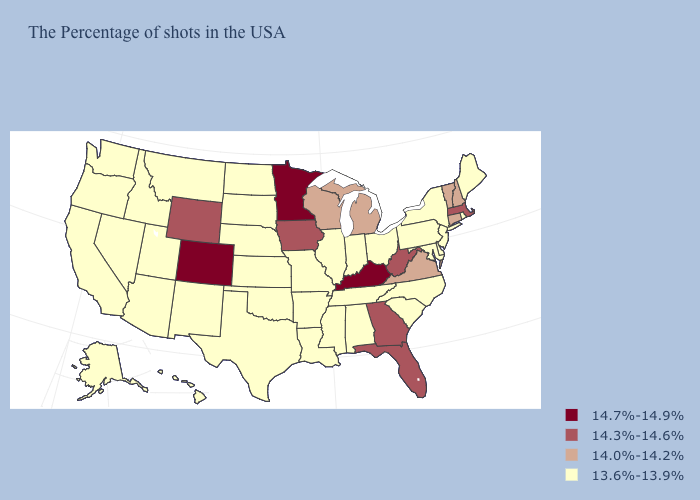How many symbols are there in the legend?
Answer briefly. 4. Name the states that have a value in the range 14.7%-14.9%?
Be succinct. Kentucky, Minnesota, Colorado. Name the states that have a value in the range 13.6%-13.9%?
Be succinct. Maine, Rhode Island, New York, New Jersey, Delaware, Maryland, Pennsylvania, North Carolina, South Carolina, Ohio, Indiana, Alabama, Tennessee, Illinois, Mississippi, Louisiana, Missouri, Arkansas, Kansas, Nebraska, Oklahoma, Texas, South Dakota, North Dakota, New Mexico, Utah, Montana, Arizona, Idaho, Nevada, California, Washington, Oregon, Alaska, Hawaii. Name the states that have a value in the range 13.6%-13.9%?
Concise answer only. Maine, Rhode Island, New York, New Jersey, Delaware, Maryland, Pennsylvania, North Carolina, South Carolina, Ohio, Indiana, Alabama, Tennessee, Illinois, Mississippi, Louisiana, Missouri, Arkansas, Kansas, Nebraska, Oklahoma, Texas, South Dakota, North Dakota, New Mexico, Utah, Montana, Arizona, Idaho, Nevada, California, Washington, Oregon, Alaska, Hawaii. Name the states that have a value in the range 14.3%-14.6%?
Keep it brief. Massachusetts, West Virginia, Florida, Georgia, Iowa, Wyoming. Which states have the lowest value in the MidWest?
Write a very short answer. Ohio, Indiana, Illinois, Missouri, Kansas, Nebraska, South Dakota, North Dakota. Which states have the lowest value in the Northeast?
Give a very brief answer. Maine, Rhode Island, New York, New Jersey, Pennsylvania. Name the states that have a value in the range 13.6%-13.9%?
Be succinct. Maine, Rhode Island, New York, New Jersey, Delaware, Maryland, Pennsylvania, North Carolina, South Carolina, Ohio, Indiana, Alabama, Tennessee, Illinois, Mississippi, Louisiana, Missouri, Arkansas, Kansas, Nebraska, Oklahoma, Texas, South Dakota, North Dakota, New Mexico, Utah, Montana, Arizona, Idaho, Nevada, California, Washington, Oregon, Alaska, Hawaii. Name the states that have a value in the range 13.6%-13.9%?
Be succinct. Maine, Rhode Island, New York, New Jersey, Delaware, Maryland, Pennsylvania, North Carolina, South Carolina, Ohio, Indiana, Alabama, Tennessee, Illinois, Mississippi, Louisiana, Missouri, Arkansas, Kansas, Nebraska, Oklahoma, Texas, South Dakota, North Dakota, New Mexico, Utah, Montana, Arizona, Idaho, Nevada, California, Washington, Oregon, Alaska, Hawaii. Name the states that have a value in the range 14.7%-14.9%?
Give a very brief answer. Kentucky, Minnesota, Colorado. Which states have the lowest value in the South?
Give a very brief answer. Delaware, Maryland, North Carolina, South Carolina, Alabama, Tennessee, Mississippi, Louisiana, Arkansas, Oklahoma, Texas. Among the states that border Arizona , which have the lowest value?
Short answer required. New Mexico, Utah, Nevada, California. Does West Virginia have the lowest value in the USA?
Be succinct. No. What is the value of New Mexico?
Quick response, please. 13.6%-13.9%. 